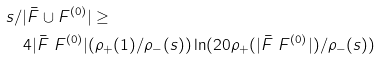<formula> <loc_0><loc_0><loc_500><loc_500>& s / | \bar { F } \cup F ^ { ( 0 ) } | \geq \\ & \quad 4 | \bar { F } \ F ^ { ( 0 ) } | ( \rho _ { + } ( 1 ) / \rho _ { - } ( s ) ) \ln ( 2 0 \rho _ { + } ( | \bar { F } \ F ^ { ( 0 ) } | ) / \rho _ { - } ( s ) )</formula> 